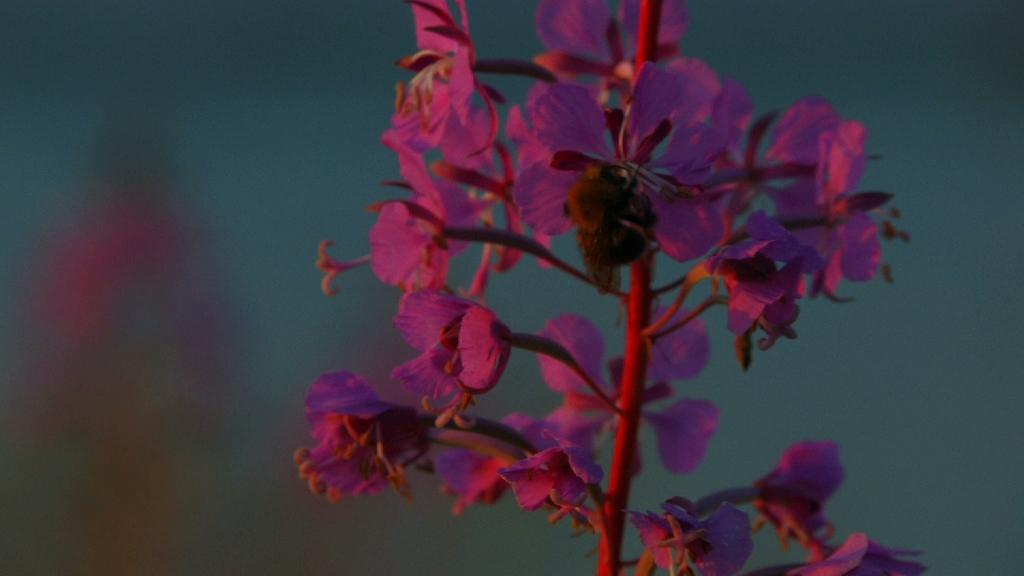What type of living organism is in the image? There is a plant in the image. What specific feature of the plant is visible? The plant has flowers. Where is the plant and flowers located in the image? The plant and flowers are in the middle of the image. What type of belief is depicted on the stage in the image? There is no stage or belief present in the image; it features a plant with flowers in the middle. Can you describe the beetle crawling on the petals of the flowers in the image? There is no beetle present in the image; it only features a plant with flowers. 